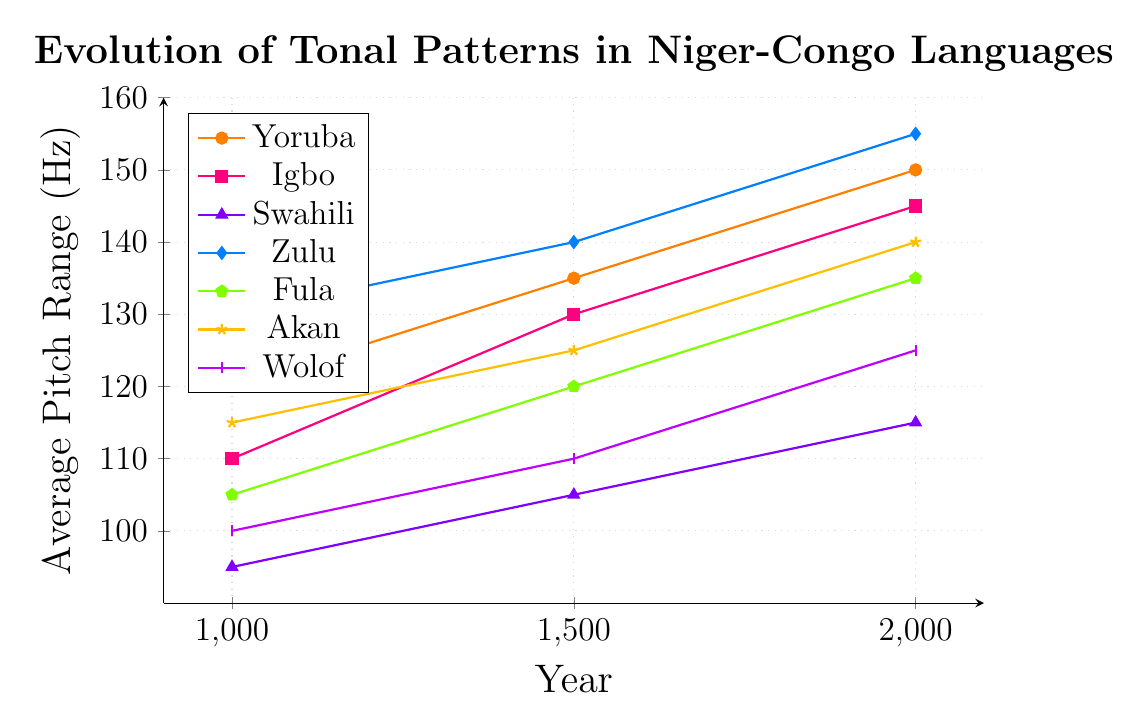Which language shows the greatest increase in average pitch range from the year 1000 to 2000? To determine the language with the greatest increase, we need to calculate the changes in average pitch range for each language between 1000 and 2000. For Yoruba: 150 - 120 = 30 Hz. For Igbo: 145 - 110 = 35 Hz. For Swahili: 115 - 95 = 20 Hz. For Zulu: 155 - 130 = 25 Hz. For Fula: 135 - 105 = 30 Hz. For Akan: 140 - 115 = 25 Hz. For Wolof: 125 - 100 = 25 Hz. The greatest increase is for Igbo, which is 35 Hz.
Answer: Igbo Between which years does Yoruba show the largest increase in average pitch range? To find this out, we compare the changes in average pitch range within the intervals. From 1000 to 1500, the change is 135 - 120 = 15 Hz. From 1500 to 2000, the change is 150 - 135 = 15 Hz. Both intervals show the same increase of 15 Hz.
Answer: 1000 to 1500 and 1500 to 2000 Which language had the lowest average pitch range in the year 1500? To determine the language with the lowest average pitch range in 1500, we look at the data points: Yoruba: 135 Hz, Igbo: 130 Hz, Swahili: 105 Hz, Zulu: 140 Hz, Fula: 120 Hz, Akan: 125 Hz, Wolof: 110 Hz. The lowest value is for Swahili at 105 Hz.
Answer: Swahili What is the average pitch range of Wolof over the given years? First, sum the pitch ranges for Wolof: 100 + 110 + 125 = 335 Hz, and then divide by the number of years: 335 / 3 = 111.67 Hz.
Answer: 111.67 Hz How does the average pitch range of Fula in 2000 compare to that of Swahili in 2000? To compare, we check the data points: Fula in 2000 is 135 Hz and Swahili in 2000 is 115 Hz. Fula's average pitch range is greater than Swahili's by 135 - 115 = 20 Hz.
Answer: Fula is greater by 20 Hz Which language's average pitch range stays within the smallest range (difference between highest and lowest values) over the years? Calculate the difference between the highest and lowest values for each language. Yoruba: 150 - 120 = 30 Hz, Igbo: 145 - 110 = 35 Hz, Swahili: 115 - 95 = 20 Hz, Zulu: 155 - 130 = 25 Hz, Fula: 135 - 105 = 30 Hz, Akan: 140 - 115 = 25 Hz, Wolof: 125 - 100 = 25 Hz. The smallest range is for Swahili, which is 20 Hz.
Answer: Swahili Which language had the steepest increase in average pitch range between 1000 and 1500? Look at the pitch range differences between 1000 and 1500. Yoruba: 135 - 120 = 15 Hz, Igbo: 130 - 110 = 20 Hz, Swahili: 105 - 95 = 10 Hz, Zulu: 140 - 130 = 10 Hz, Fula: 120 - 105 = 15 Hz, Akan: 125 - 115 = 10 Hz, Wolof: 110 - 100 = 10 Hz. Igbo had the steepest increase of 20 Hz.
Answer: Igbo What is the median average pitch range for all languages in the year 2000? Collect the pitch ranges for 2000 for all languages: Yoruba: 150, Igbo: 145, Swahili: 115, Zulu: 155, Fula: 135, Akan: 140, Wolof: 125. Arrange them in ascending order: 115, 125, 135, 140, 145, 150, 155. The median value, being the middle one, is 140 Hz.
Answer: 140 Hz 